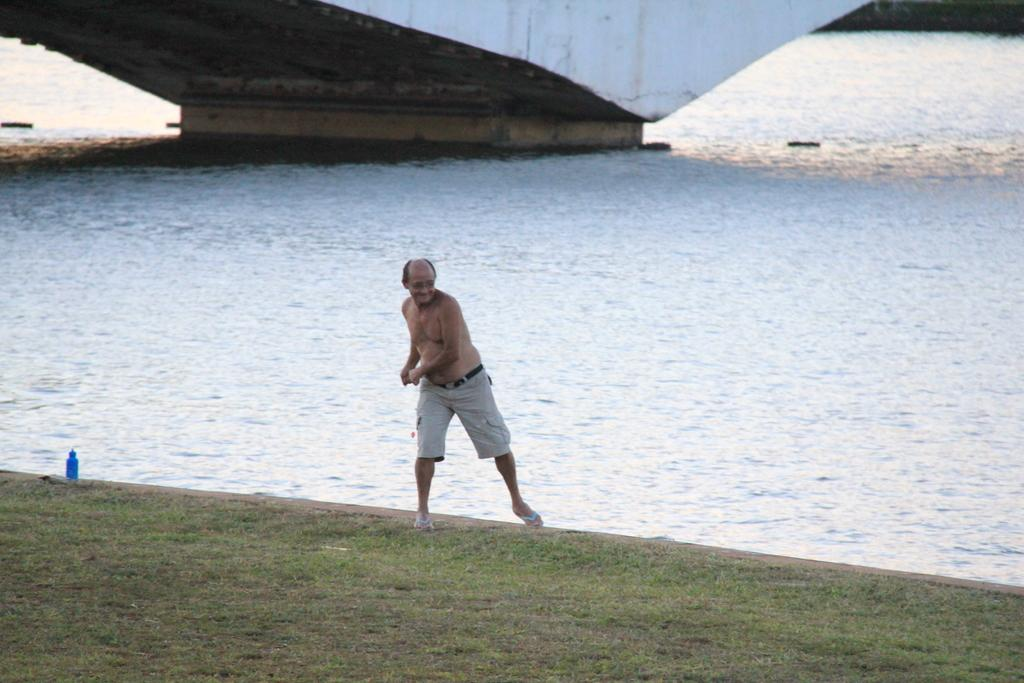What is the main subject of the image? There is a man standing in the image. What is at the bottom of the image? There is grass at the bottom of the image. What object can be seen on the left side of the image? There is a bottle on the left side of the image. What can be seen in the background of the image? There is water visible in the background of the image. How many rings can be seen on the man's fingers in the image? There are no rings visible on the man's fingers in the image. What type of show is the man performing in the image? There is no show or performance taking place in the image; it simply shows a man standing. 